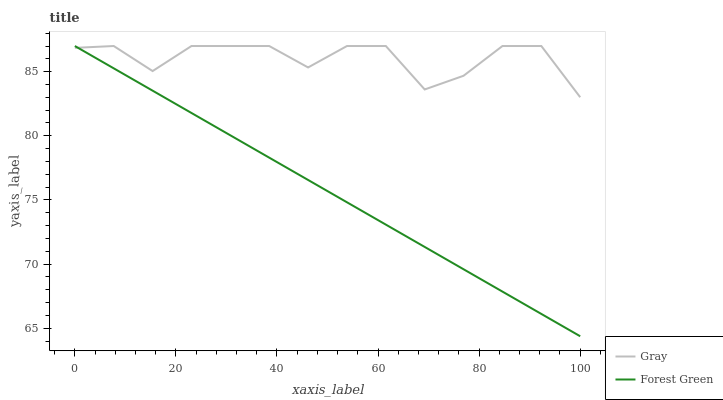Does Forest Green have the minimum area under the curve?
Answer yes or no. Yes. Does Gray have the maximum area under the curve?
Answer yes or no. Yes. Does Forest Green have the maximum area under the curve?
Answer yes or no. No. Is Forest Green the smoothest?
Answer yes or no. Yes. Is Gray the roughest?
Answer yes or no. Yes. Is Forest Green the roughest?
Answer yes or no. No. 